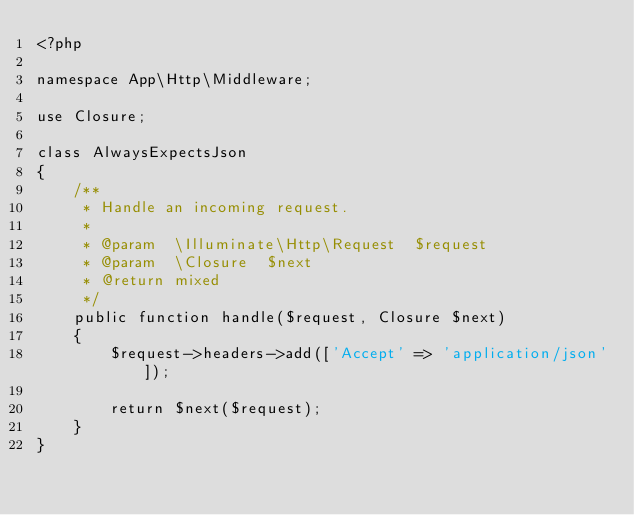Convert code to text. <code><loc_0><loc_0><loc_500><loc_500><_PHP_><?php

namespace App\Http\Middleware;

use Closure;

class AlwaysExpectsJson
{
    /**
     * Handle an incoming request.
     *
     * @param  \Illuminate\Http\Request  $request
     * @param  \Closure  $next
     * @return mixed
     */
    public function handle($request, Closure $next)
    {
        $request->headers->add(['Accept' => 'application/json']);

        return $next($request);
    }
}</code> 